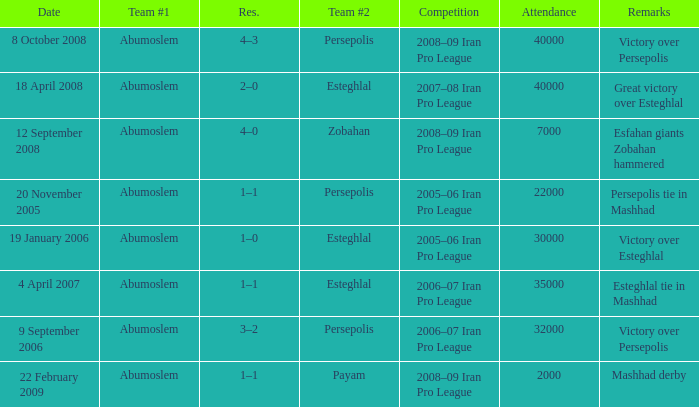What was the res for the game against Payam? 1–1. 